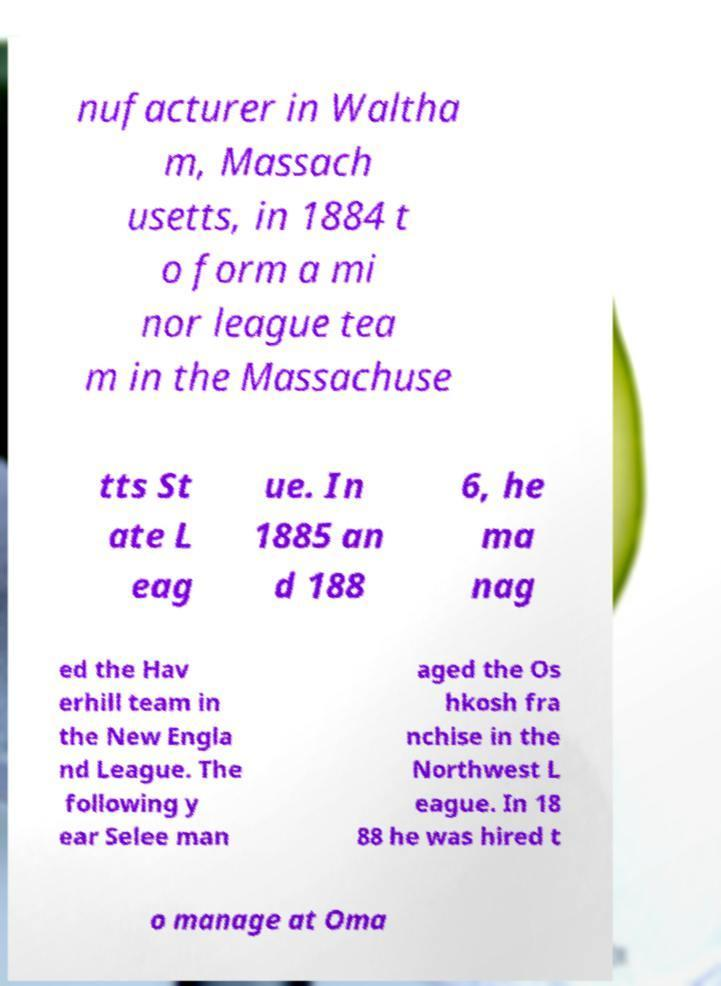Can you accurately transcribe the text from the provided image for me? nufacturer in Waltha m, Massach usetts, in 1884 t o form a mi nor league tea m in the Massachuse tts St ate L eag ue. In 1885 an d 188 6, he ma nag ed the Hav erhill team in the New Engla nd League. The following y ear Selee man aged the Os hkosh fra nchise in the Northwest L eague. In 18 88 he was hired t o manage at Oma 